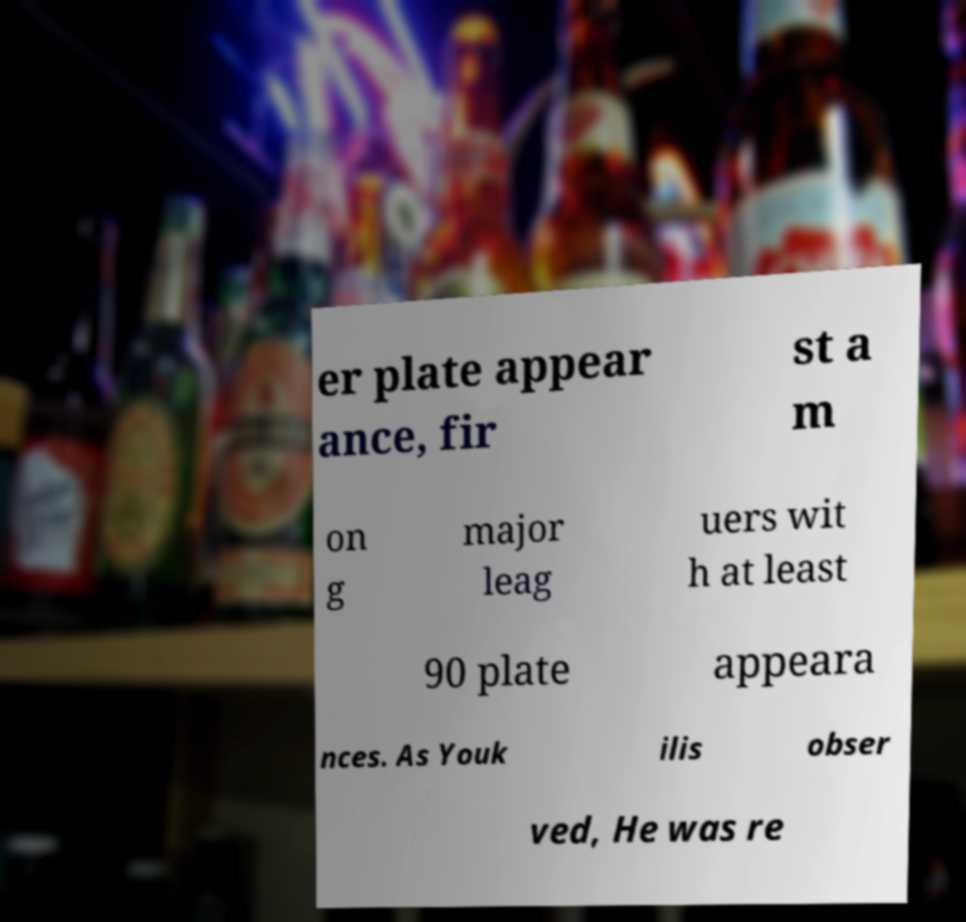Can you accurately transcribe the text from the provided image for me? er plate appear ance, fir st a m on g major leag uers wit h at least 90 plate appeara nces. As Youk ilis obser ved, He was re 